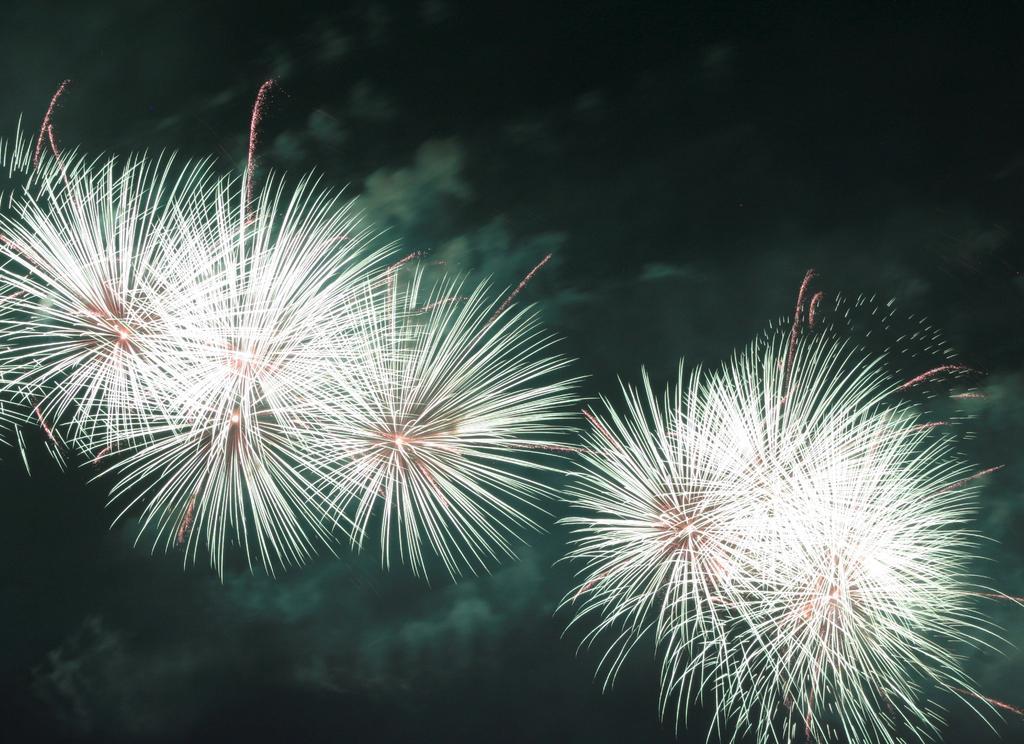Describe this image in one or two sentences. In this picture we can observe some crackers lighten up into the air. We can observe white and red color lights here. In the background there is a sky which is dark. 